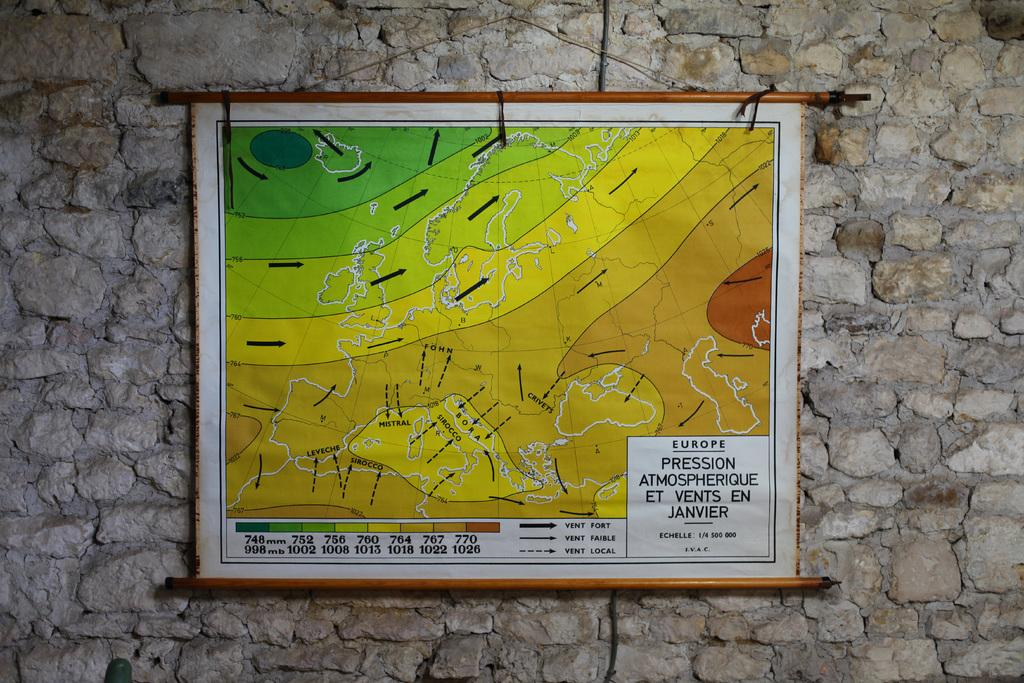What is the main object in the image? There is a board in the image. Where is the board located? The board is on a stone wall. What can be found on the board? The board contains directions and text. How many frogs are sitting on the board in the image? There are no frogs present in the image. What type of skin is visible on the board in the image? The board does not have skin; it is a flat surface with text and directions. 